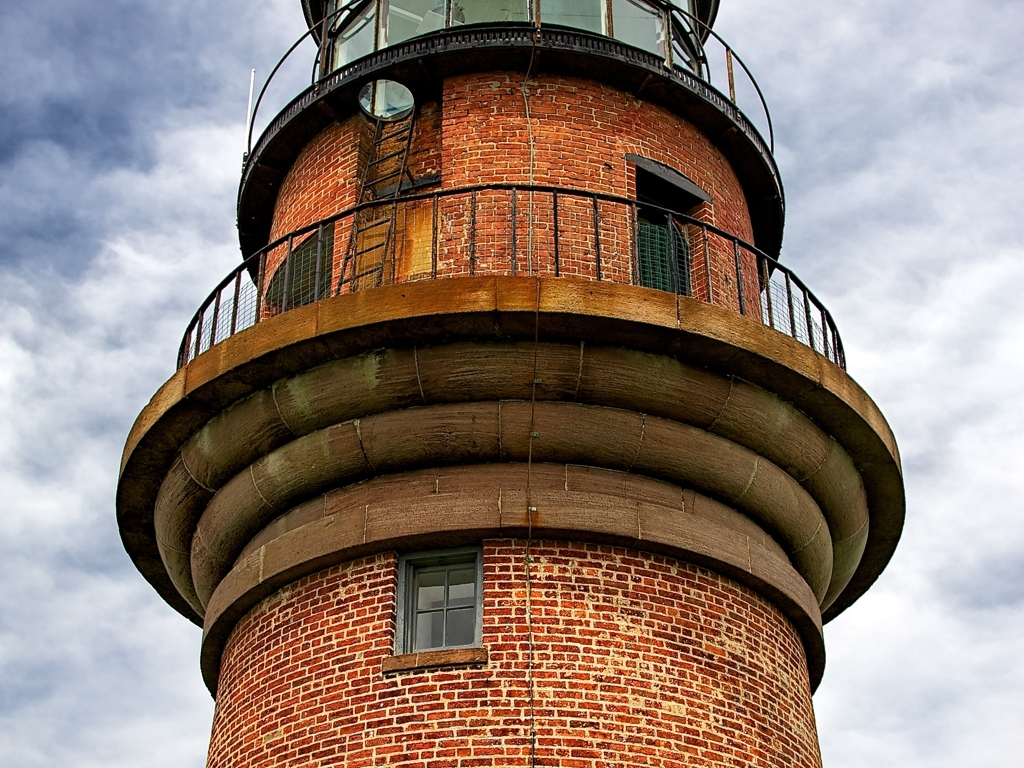Does the image have any noise or loss of texture information? Upon close inspection, the image appears to be of high quality, with no significant noise or loss of texture information. The brickwork of the tower is crisp and detailed, and the differentiation of materials between the metal elements and the stonework is clearly visible. This suggests that the image has been captured with a high-resolution camera and has likely not undergone destructive compression which could have compromised the image quality. 